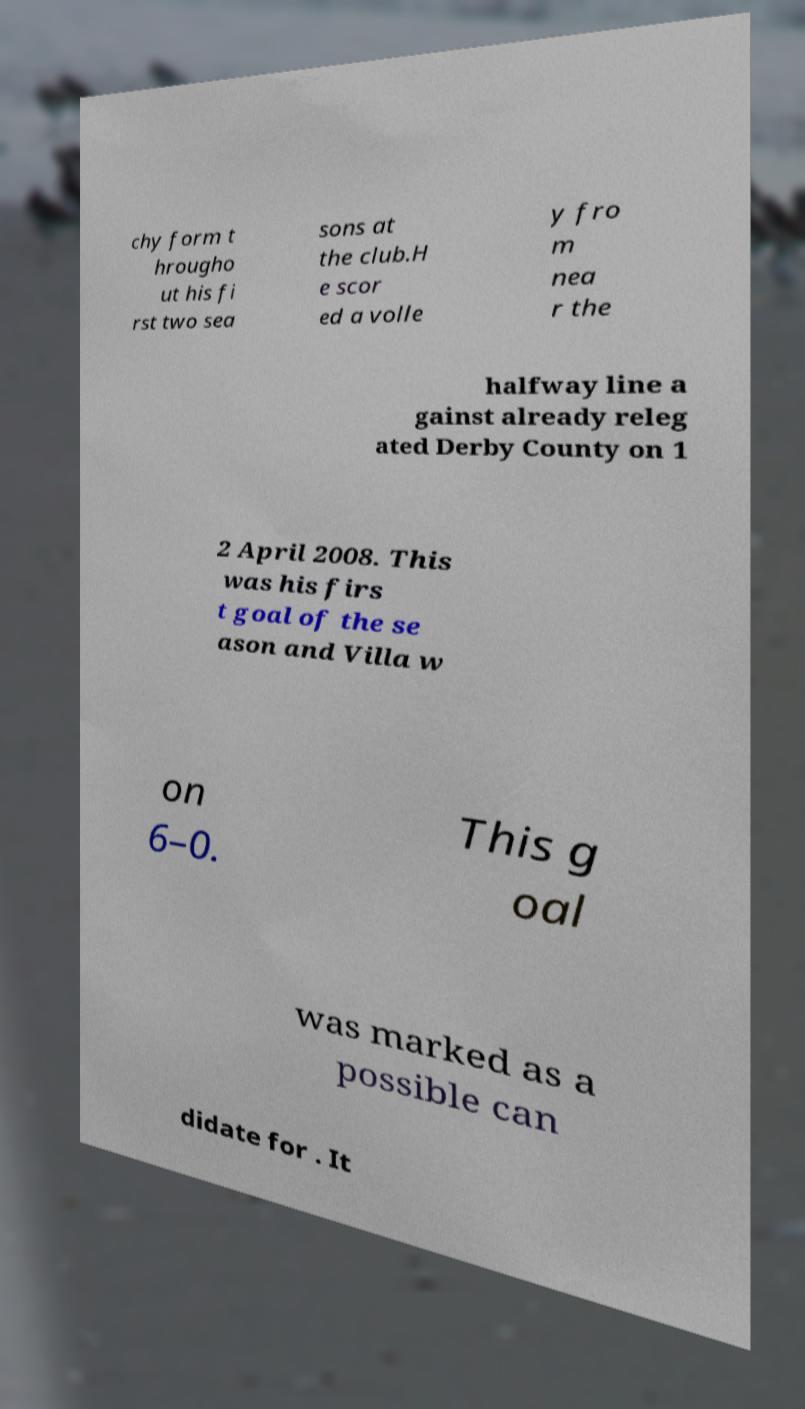Could you assist in decoding the text presented in this image and type it out clearly? chy form t hrougho ut his fi rst two sea sons at the club.H e scor ed a volle y fro m nea r the halfway line a gainst already releg ated Derby County on 1 2 April 2008. This was his firs t goal of the se ason and Villa w on 6–0. This g oal was marked as a possible can didate for . It 